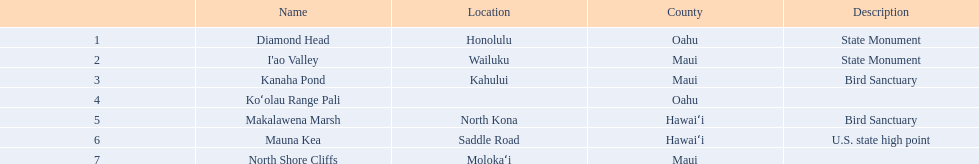What are all of the national natural landmarks in hawaii? Diamond Head, I'ao Valley, Kanaha Pond, Koʻolau Range Pali, Makalawena Marsh, Mauna Kea, North Shore Cliffs. Which ones of those national natural landmarks in hawaii are in the county of hawai'i? Makalawena Marsh, Mauna Kea. Which is the only national natural landmark in hawaii that is also a u.s. state high point? Mauna Kea. 